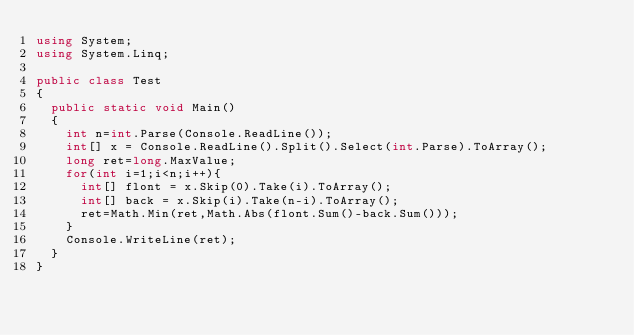<code> <loc_0><loc_0><loc_500><loc_500><_C#_>using System;
using System.Linq;
 
public class Test
{
	public static void Main()
	{
		int n=int.Parse(Console.ReadLine());
		int[] x = Console.ReadLine().Split().Select(int.Parse).ToArray();
		long ret=long.MaxValue;
		for(int i=1;i<n;i++){
			int[] flont = x.Skip(0).Take(i).ToArray();
			int[] back = x.Skip(i).Take(n-i).ToArray();
			ret=Math.Min(ret,Math.Abs(flont.Sum()-back.Sum()));
		}
		Console.WriteLine(ret);
	}
}</code> 